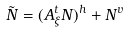Convert formula to latex. <formula><loc_0><loc_0><loc_500><loc_500>\tilde { N } = ( A _ { \xi } ^ { t } N ) ^ { h } + N ^ { v }</formula> 